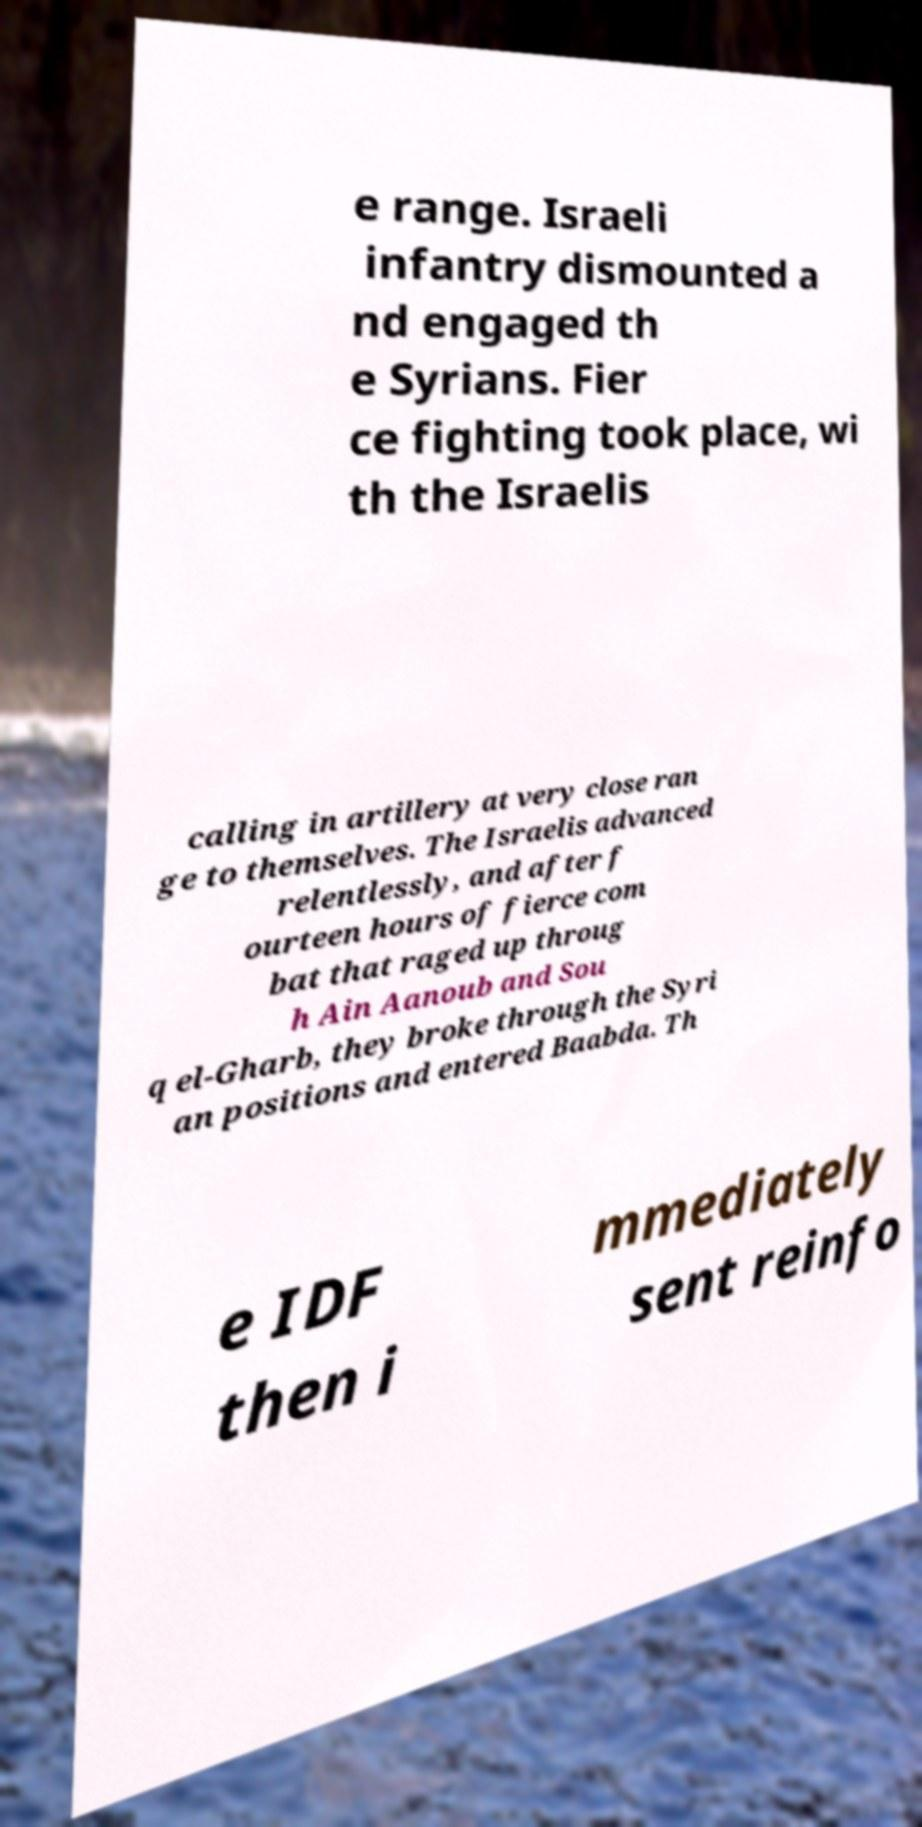What messages or text are displayed in this image? I need them in a readable, typed format. e range. Israeli infantry dismounted a nd engaged th e Syrians. Fier ce fighting took place, wi th the Israelis calling in artillery at very close ran ge to themselves. The Israelis advanced relentlessly, and after f ourteen hours of fierce com bat that raged up throug h Ain Aanoub and Sou q el-Gharb, they broke through the Syri an positions and entered Baabda. Th e IDF then i mmediately sent reinfo 